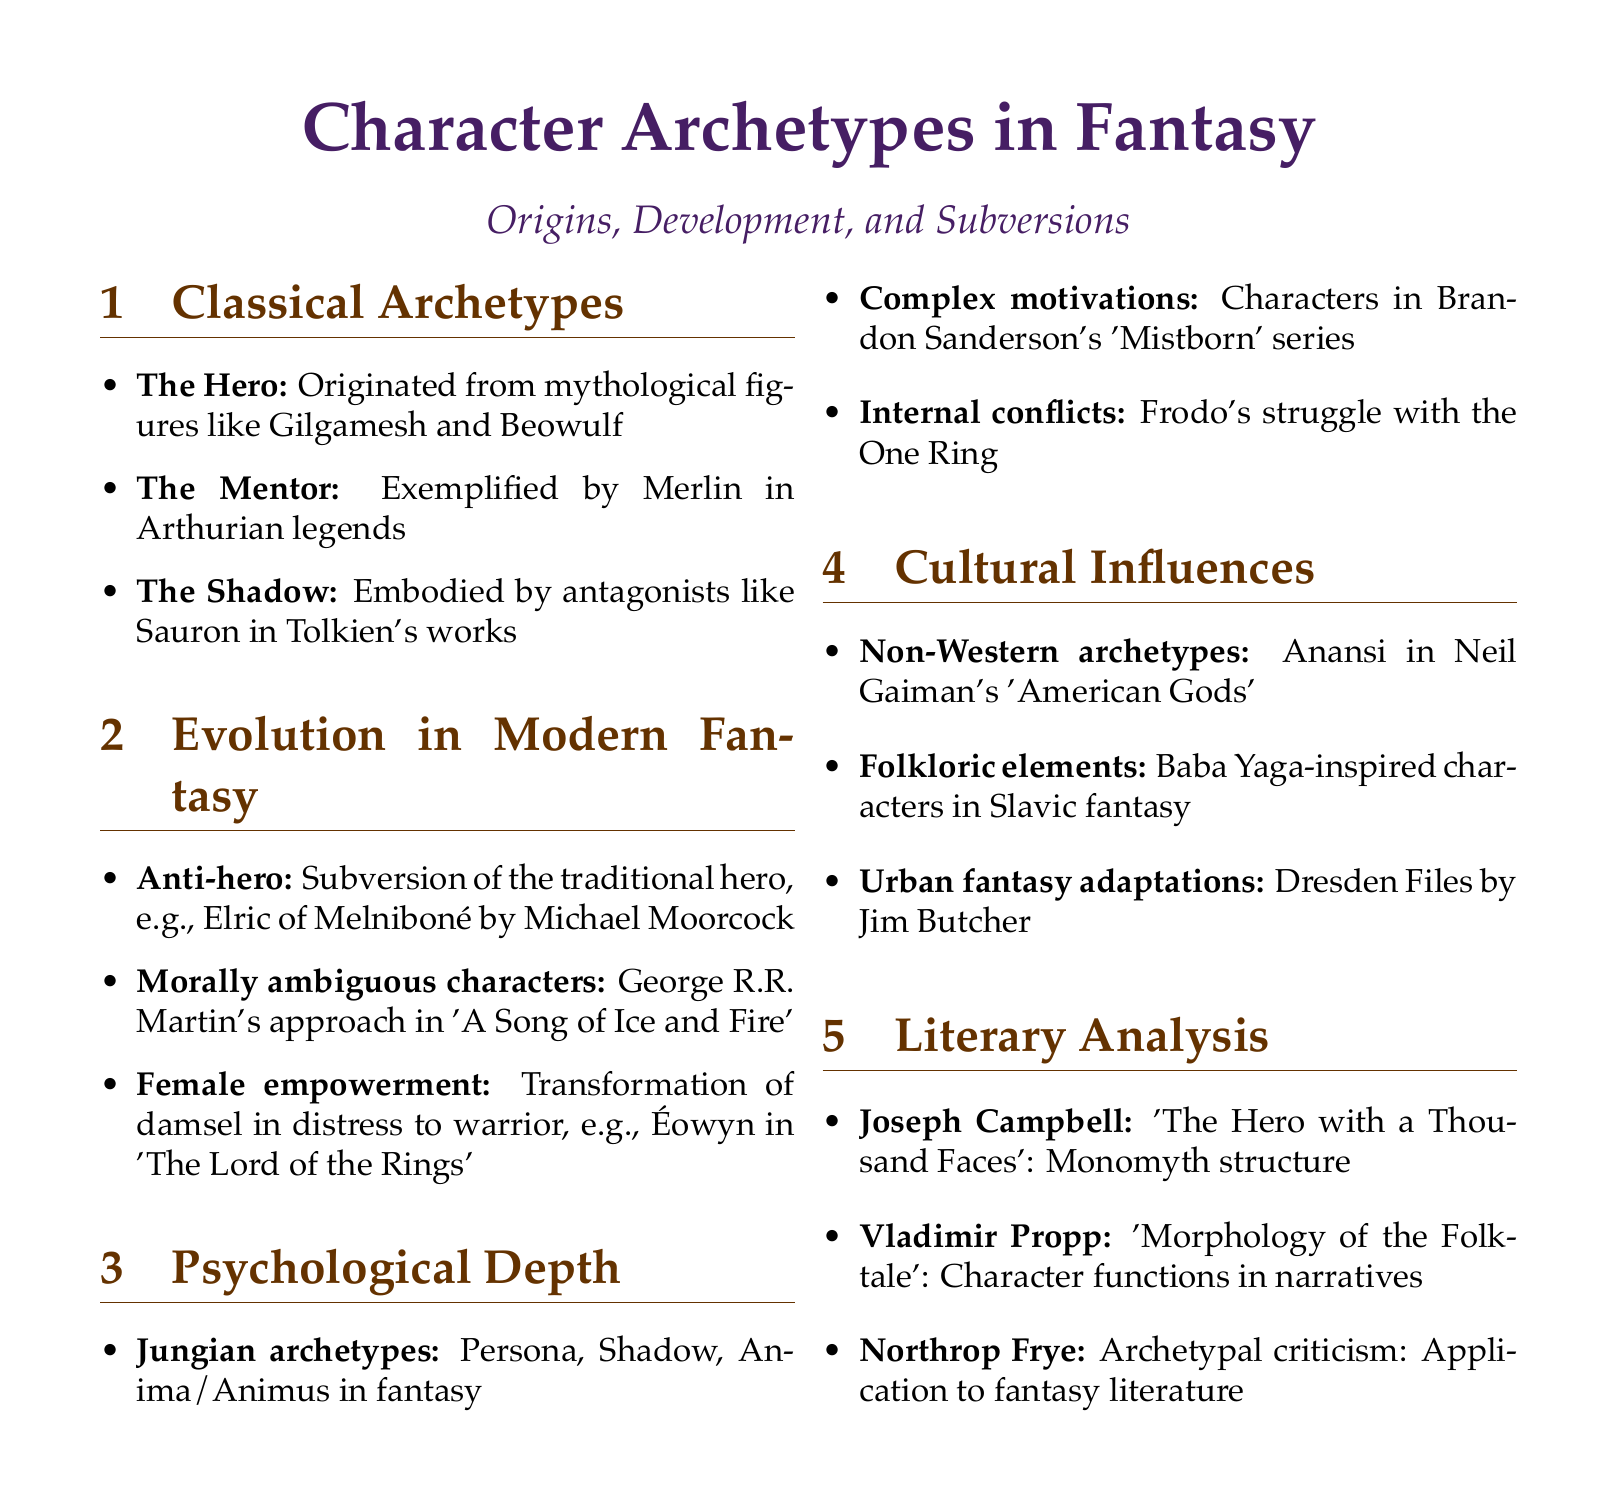What is the name of the hero archetype mentioned? The document identifies "The Hero" as an archetype, referencing mythological figures like Gilgamesh and Beowulf.
Answer: The Hero Who exemplifies the mentor archetype? The document mentions Merlin from Arthurian legends as a prime example of the mentor archetype.
Answer: Merlin What modern character represents an anti-hero? The document illustrates the anti-hero archetype with the character Elric of Melniboné from Michael Moorcock's works.
Answer: Elric of Melniboné Which author is associated with morally ambiguous characters in fantasy? George R.R. Martin's approach to character development in 'A Song of Ice and Fire' is highlighted in the document.
Answer: George R.R. Martin What psychological framework is used in modern fantasy according to the document? The document references Jungian archetypes, including Persona, Shadow, Anima/Animus, as a psychological framework.
Answer: Jungian archetypes Who wrote 'The Hero with a Thousand Faces'? The document states that Joseph Campbell is the author of this influential work on monomyth structure.
Answer: Joseph Campbell What type of elements does the document mention in cultural influences? The document indicates the presence of folkloric elements, specifically mentioning characters inspired by Baba Yaga in Slavic fantasy.
Answer: Folkloric elements Which series features complex motivations as discussed in the document? Brandon Sanderson's 'Mistborn' series is singled out in the document for its exploration of character motivations.
Answer: Mistborn What literary criticism approach is applied to fantasy literature? Northrop Frye's archetypal criticism is mentioned as a method of analysis within the document.
Answer: Archetypal criticism 